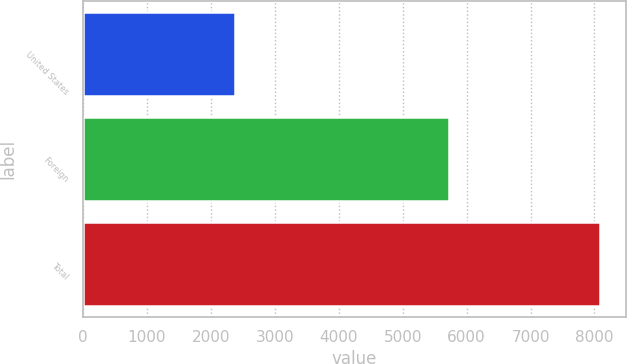Convert chart. <chart><loc_0><loc_0><loc_500><loc_500><bar_chart><fcel>United States<fcel>Foreign<fcel>Total<nl><fcel>2373<fcel>5720<fcel>8093<nl></chart> 